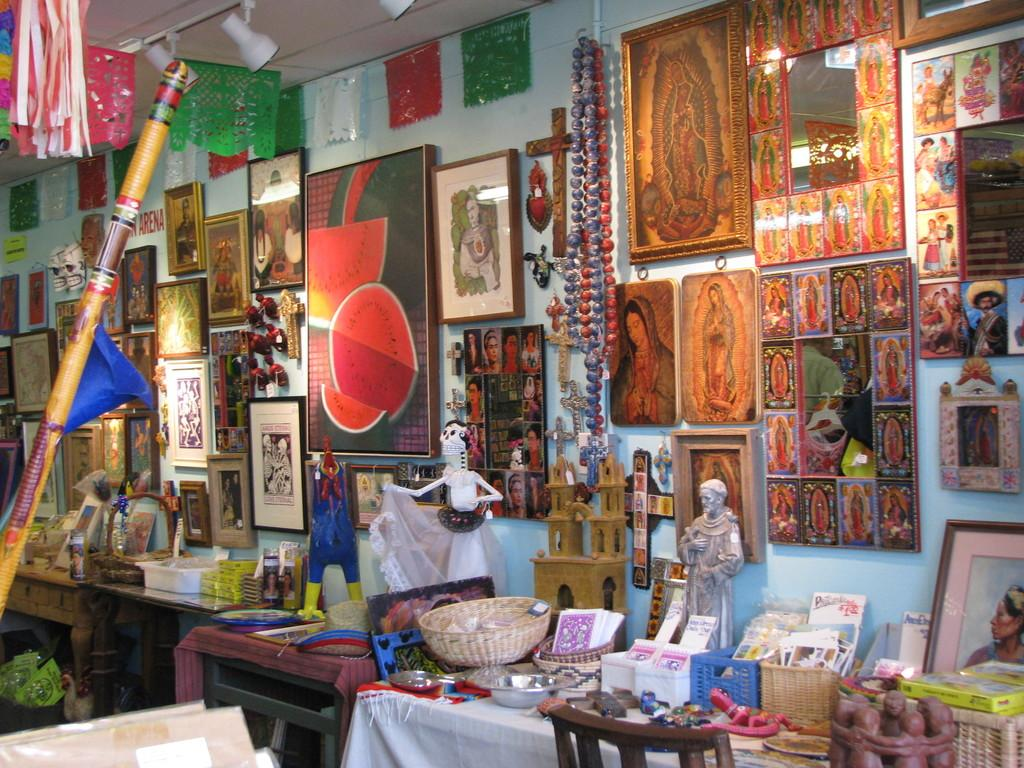What is the main piece of furniture in the image? There is a table in the image. What is on top of the table? The table has a statue on it, as well as cards and bowls. What can be seen in the background of the image? There is a wall in the background of the image, with photo frames and other objects visible. What type of leather material is used to cover the hydrant in the image? There is no hydrant present in the image, so it is not possible to determine the type of leather material used to cover it. 